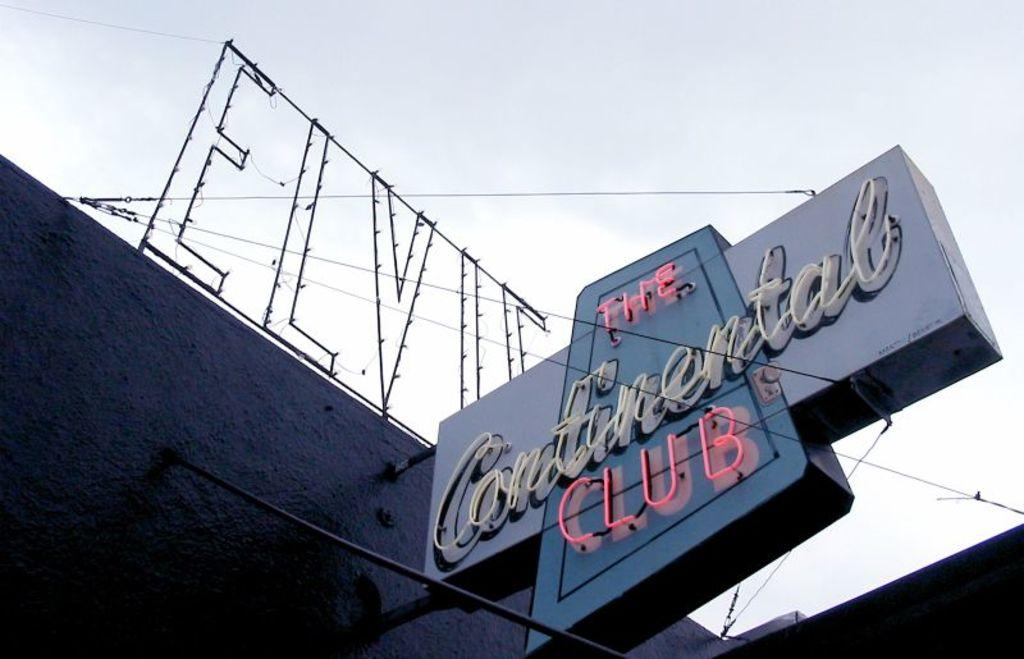What type of structure can be seen in the image? There is a wall in the image. What is attached to the wall? There is a name board in the image. What can be seen in the background of the image? The sky is visible in the background of the image. What is the name of the daughter of the person whose name is on the name board? There is no information about a daughter or a person's name in the image, so this question cannot be answered. 